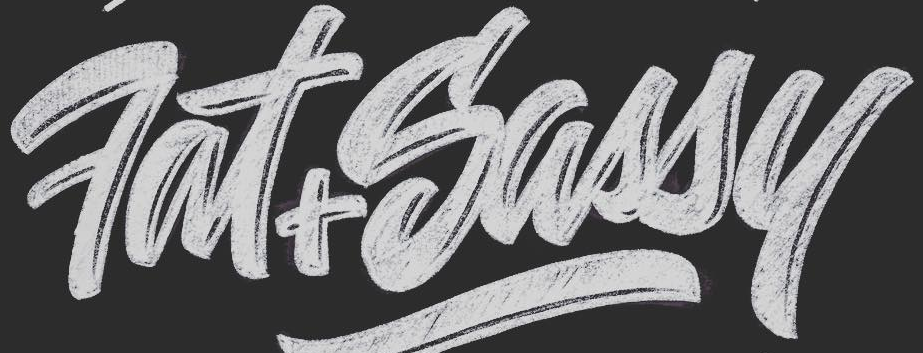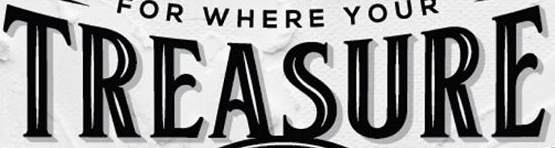What words are shown in these images in order, separated by a semicolon? Fat+Sassy; TREASURE 